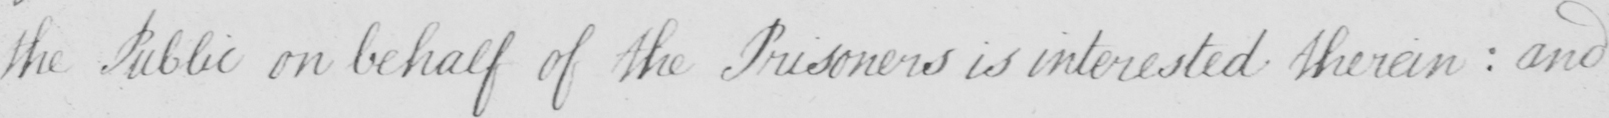Can you tell me what this handwritten text says? the Public on behalf of the Prisoners is interested therein  :  and 